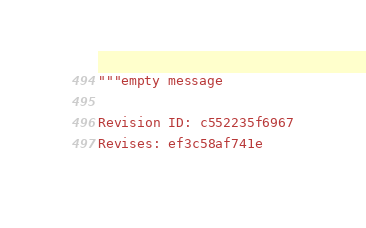<code> <loc_0><loc_0><loc_500><loc_500><_Python_>"""empty message

Revision ID: c552235f6967
Revises: ef3c58af741e</code> 